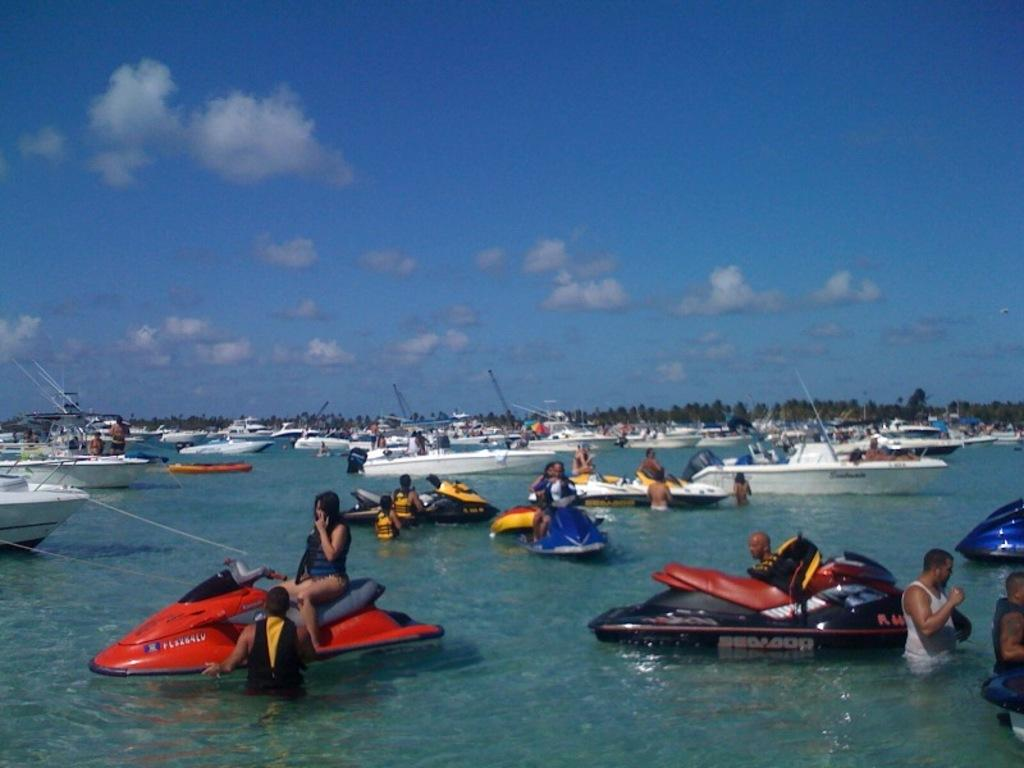What type of vehicles are present in the image? There are boats in the image. What are the people in the boats doing? People are sitting in the boats. What activity can be seen involving people in the water? People are swimming in the image. What type of natural environment is visible in the image? There are trees visible in the image. What is the primary substance visible in the image? There is water visible in the image. What is visible above the water and trees in the image? The sky is visible in the image. What is the rate of the clouds moving in the image? There are no clouds visible in the image, so it is not possible to determine the rate at which they might be moving. What type of glass is being used by the people swimming in the image? There is no glass present in the image; people are swimming in water. 